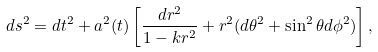Convert formula to latex. <formula><loc_0><loc_0><loc_500><loc_500>d s ^ { 2 } = d t ^ { 2 } + a ^ { 2 } ( t ) \left [ \frac { d r ^ { 2 } } { 1 - k r ^ { 2 } } + r ^ { 2 } ( d \theta ^ { 2 } + \sin ^ { 2 } \theta d \phi ^ { 2 } ) \right ] ,</formula> 